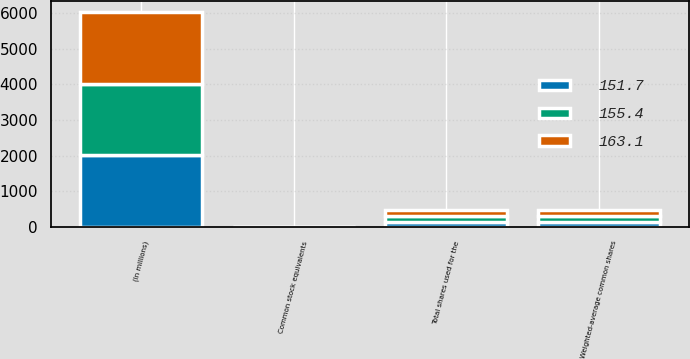Convert chart. <chart><loc_0><loc_0><loc_500><loc_500><stacked_bar_chart><ecel><fcel>(In millions)<fcel>Weighted-average common shares<fcel>Common stock equivalents<fcel>Total shares used for the<nl><fcel>151.7<fcel>2010<fcel>150.4<fcel>1.3<fcel>151.7<nl><fcel>155.4<fcel>2009<fcel>154.5<fcel>0.9<fcel>155.4<nl><fcel>163.1<fcel>2008<fcel>162<fcel>1.1<fcel>163.1<nl></chart> 